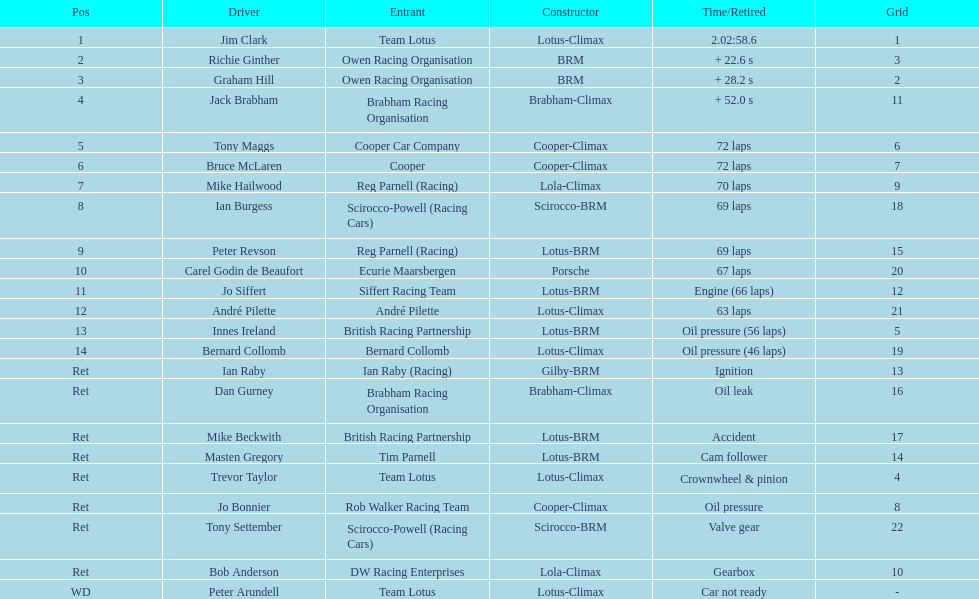Which one arrived first, tony maggs or jo siffert? Tony Maggs. 